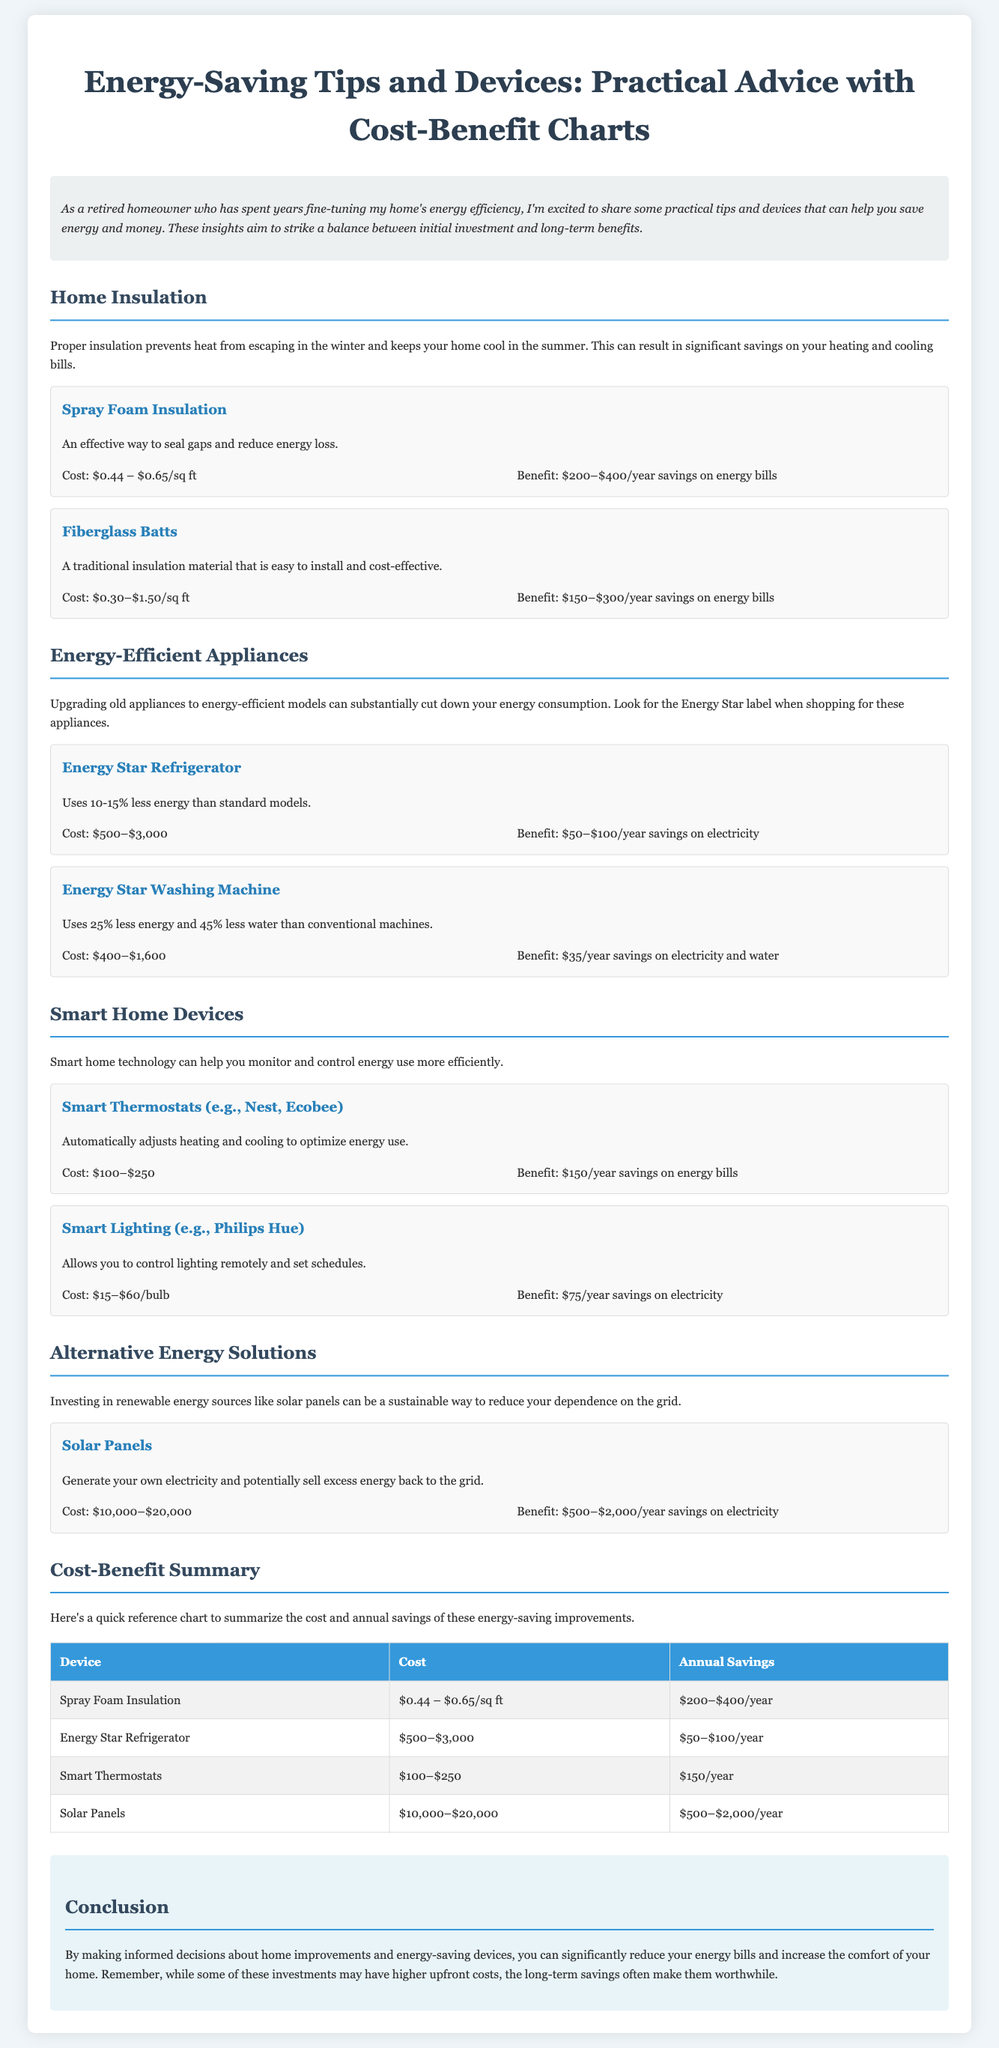What is the cost range for Spray Foam Insulation? The cost range for Spray Foam Insulation is $0.44 to $0.65 per square foot as mentioned in the document.
Answer: $0.44 – $0.65/sq ft What appliance is compared to the Energy Star Washing Machine in terms of energy savings? The document compares the Energy Star Refrigerator to the Energy Star Washing Machine, highlighting their energy efficiency benefits.
Answer: Energy Star Refrigerator What is the benefit of Installing Smart Thermostats? The benefit of Installing Smart Thermostats is that they provide $150 of annual savings on energy bills as presented in the document.
Answer: $150/year What is the annual savings range for Solar Panels? The annual savings for Solar Panels is between $500 and $2,000 as indicated in the cost-benefit section.
Answer: $500–$2,000/year What is the primary focus of this presentation slide? The primary focus of this presentation slide is to provide energy-saving tips and devices along with their cost-benefit analysis to homeowners.
Answer: Energy-saving tips and devices Which insulation type is noted as a traditional material that is easy to install? Fiberglass Batts is noted as a traditional insulation material that is easy to install in the document.
Answer: Fiberglass Batts In which section are smart home technology solutions discussed? Smart home technology solutions are discussed in the "Smart Home Devices" section of the document.
Answer: Smart Home Devices What is the maximum cost for Energy Star Appliances mentioned? The maximum cost for Energy Star Appliances mentioned is $3,000 for an Energy Star Refrigerator according to the details in the slides.
Answer: $3,000 